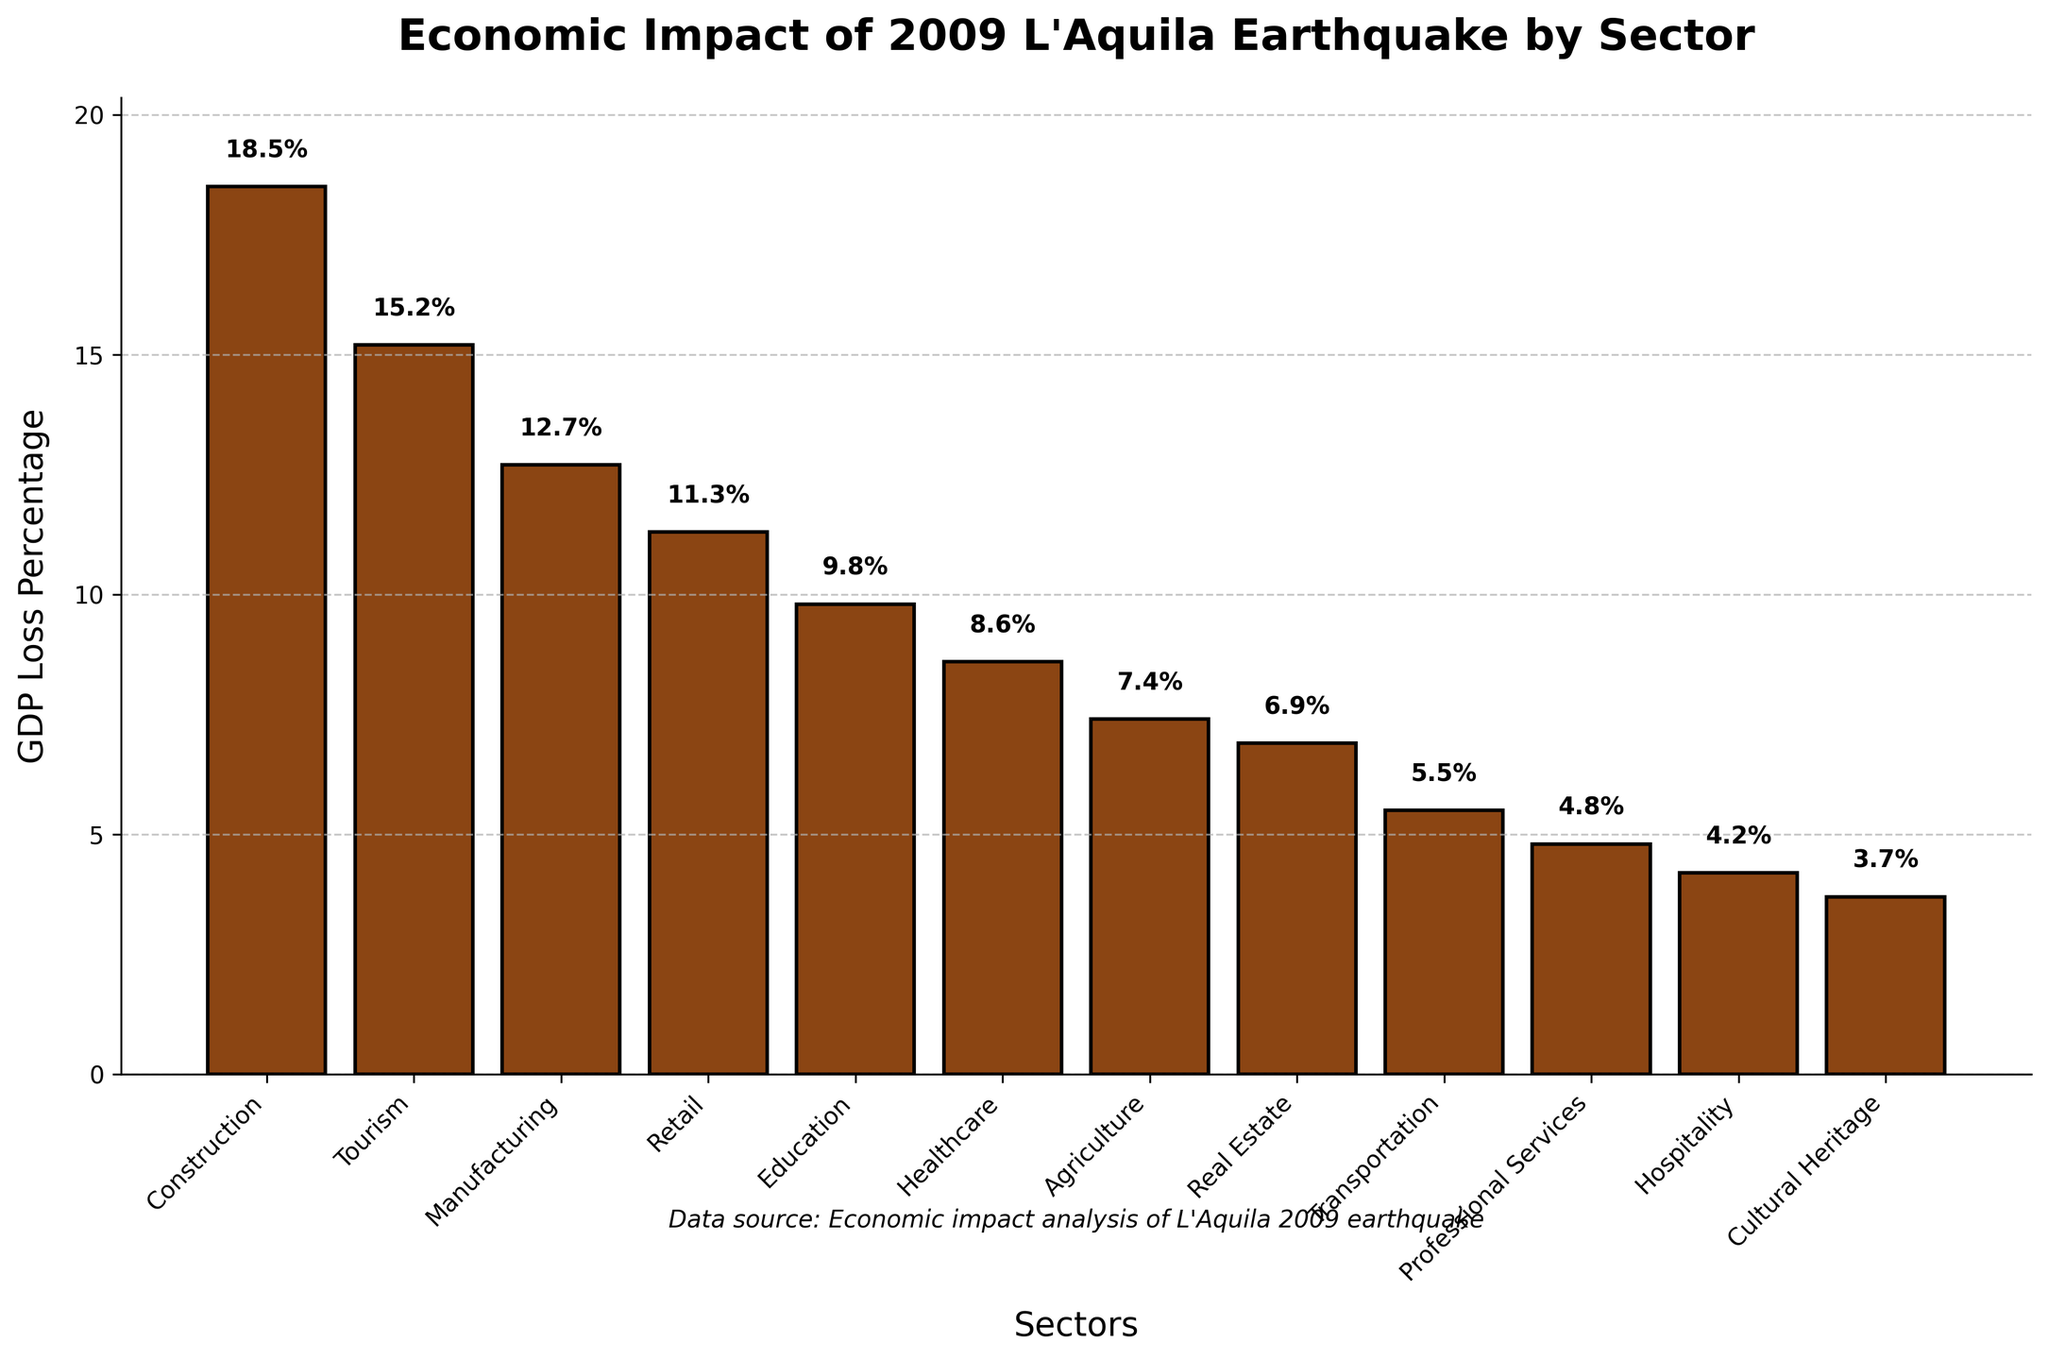Which sector experienced the highest GDP loss percentage? Identify the bar with the highest value in the plot, which represents the sector with the highest GDP loss percentage. In this chart, the Construction sector has the tallest bar indicating the highest loss.
Answer: Construction What is the total GDP loss percentage for Tourism and Manufacturing sectors combined? Add the GDP loss percentages for Tourism (15.2%) and Manufacturing (12.7%) sectors as indicated by the bar heights. The sum is 15.2 + 12.7.
Answer: 27.9% How much more GDP loss percentage did the Construction sector experience compared to the Healthcare sector? Subtract the GDP loss percentage of Healthcare (8.6%) from that of Construction (18.5%). The difference is 18.5 - 8.6.
Answer: 9.9% Which sector had nearly half the GDP loss percentage compared to the Construction sector? Compare the GDP loss percentage of Construction (18.5%) to other sectors. The Healthcare sector has a GDP loss percentage of 8.6%, which is approximately half of 18.5%.
Answer: Healthcare What is the average GDP loss percentage of the Agriculture, Real Estate, and Transportation sectors? Add the GDP loss percentages of Agriculture (7.4%), Real Estate (6.9%), and Transportation (5.5%) and then divide by 3. The sum is 7.4 + 6.9 + 5.5 = 19.8 and the average is 19.8 / 3.
Answer: 6.6% Which sector had the lowest GDP loss percentage from the earthquake? Identify the bar with the shortest height in the plot. The Cultural Heritage sector has the shortest bar indicating the lowest GDP loss percentage.
Answer: Cultural Heritage Is the GDP loss percentage of Professional Services higher or lower than that of Transport? Compare the GDP loss percentages of Professional Services (4.8%) and Transportation (5.5%) as indicated by their respective bar heights. The Professional Services sector has a lower value.
Answer: Lower What is the combined GDP loss percentage for all sectors that experienced less than 7% GDP loss? Add the GDP loss percentages of all sectors with loss less than 7%. These are Real Estate (6.9%), Transportation (5.5%), Professional Services (4.8%), Hospitality (4.2%), Cultural Heritage (3.7%). The sum is 6.9 + 5.5 + 4.8 + 4.2 + 3.7.
Answer: 25.1% Which sectors experienced between 8% and 12% GDP loss? Identify the bars with heights indicating a GDP loss between 8% and 12%. The Retail (11.3%) and Healthcare (8.6%) sectors fall within this range.
Answer: Retail, Healthcare 